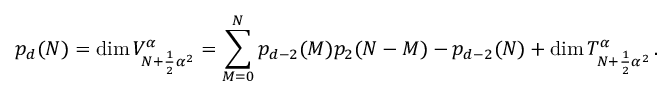<formula> <loc_0><loc_0><loc_500><loc_500>p _ { d } ( N ) = d i m \, V _ { N + \frac { 1 } { 2 } { \alpha } ^ { 2 } } ^ { \alpha } = \sum _ { M = 0 } ^ { N } p _ { d - 2 } ( M ) p _ { 2 } ( N - M ) - p _ { d - 2 } ( N ) + d i m \, T _ { N + \frac { 1 } { 2 } { \alpha } ^ { 2 } } ^ { \alpha } \, .</formula> 